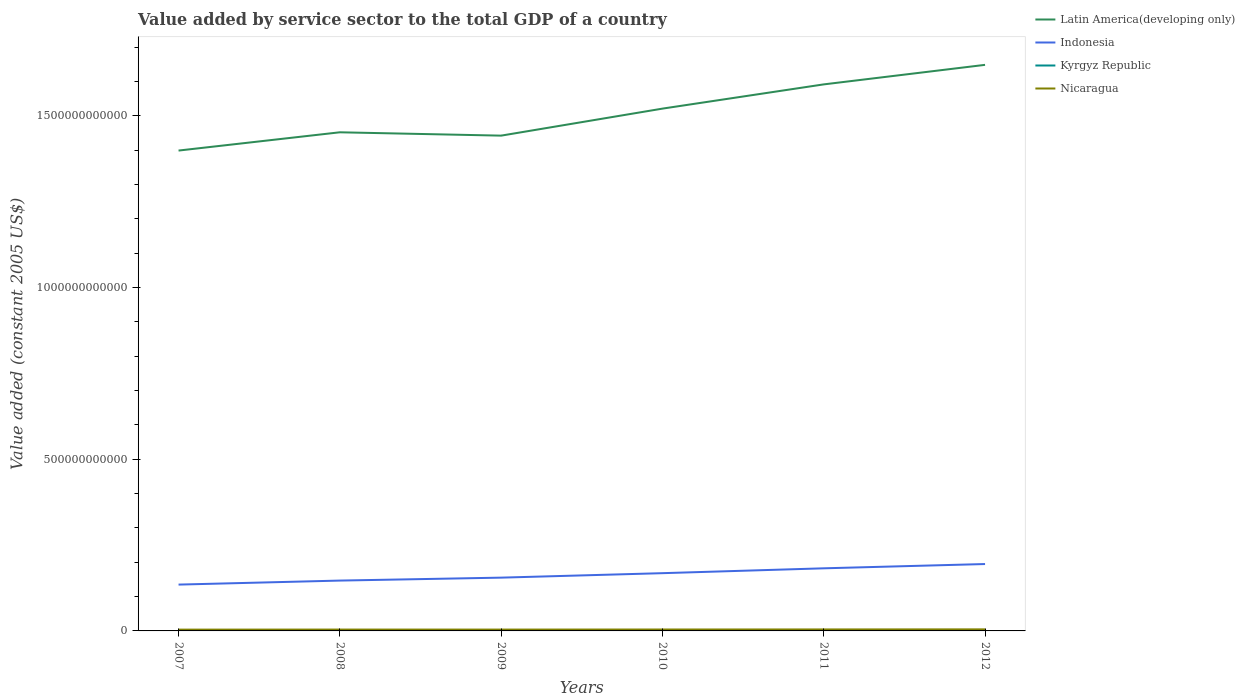How many different coloured lines are there?
Your answer should be very brief. 4. Across all years, what is the maximum value added by service sector in Kyrgyz Republic?
Ensure brevity in your answer.  1.42e+09. In which year was the value added by service sector in Indonesia maximum?
Ensure brevity in your answer.  2007. What is the total value added by service sector in Kyrgyz Republic in the graph?
Your response must be concise. -1.62e+08. What is the difference between the highest and the second highest value added by service sector in Kyrgyz Republic?
Your answer should be very brief. 3.87e+08. Is the value added by service sector in Indonesia strictly greater than the value added by service sector in Latin America(developing only) over the years?
Your answer should be compact. Yes. How many lines are there?
Your response must be concise. 4. How many years are there in the graph?
Provide a short and direct response. 6. What is the difference between two consecutive major ticks on the Y-axis?
Provide a short and direct response. 5.00e+11. Does the graph contain any zero values?
Your answer should be compact. No. How many legend labels are there?
Your response must be concise. 4. How are the legend labels stacked?
Offer a very short reply. Vertical. What is the title of the graph?
Keep it short and to the point. Value added by service sector to the total GDP of a country. Does "Iraq" appear as one of the legend labels in the graph?
Give a very brief answer. No. What is the label or title of the Y-axis?
Keep it short and to the point. Value added (constant 2005 US$). What is the Value added (constant 2005 US$) in Latin America(developing only) in 2007?
Keep it short and to the point. 1.40e+12. What is the Value added (constant 2005 US$) of Indonesia in 2007?
Offer a very short reply. 1.35e+11. What is the Value added (constant 2005 US$) in Kyrgyz Republic in 2007?
Give a very brief answer. 1.42e+09. What is the Value added (constant 2005 US$) in Nicaragua in 2007?
Your response must be concise. 3.76e+09. What is the Value added (constant 2005 US$) in Latin America(developing only) in 2008?
Provide a succinct answer. 1.45e+12. What is the Value added (constant 2005 US$) of Indonesia in 2008?
Your response must be concise. 1.47e+11. What is the Value added (constant 2005 US$) of Kyrgyz Republic in 2008?
Your response must be concise. 1.60e+09. What is the Value added (constant 2005 US$) in Nicaragua in 2008?
Keep it short and to the point. 3.97e+09. What is the Value added (constant 2005 US$) in Latin America(developing only) in 2009?
Offer a terse response. 1.44e+12. What is the Value added (constant 2005 US$) of Indonesia in 2009?
Provide a short and direct response. 1.55e+11. What is the Value added (constant 2005 US$) in Kyrgyz Republic in 2009?
Provide a short and direct response. 1.62e+09. What is the Value added (constant 2005 US$) in Nicaragua in 2009?
Offer a very short reply. 3.93e+09. What is the Value added (constant 2005 US$) of Latin America(developing only) in 2010?
Provide a short and direct response. 1.52e+12. What is the Value added (constant 2005 US$) of Indonesia in 2010?
Offer a terse response. 1.68e+11. What is the Value added (constant 2005 US$) in Kyrgyz Republic in 2010?
Give a very brief answer. 1.62e+09. What is the Value added (constant 2005 US$) of Nicaragua in 2010?
Your answer should be compact. 4.13e+09. What is the Value added (constant 2005 US$) in Latin America(developing only) in 2011?
Your answer should be compact. 1.59e+12. What is the Value added (constant 2005 US$) in Indonesia in 2011?
Keep it short and to the point. 1.82e+11. What is the Value added (constant 2005 US$) of Kyrgyz Republic in 2011?
Give a very brief answer. 1.76e+09. What is the Value added (constant 2005 US$) of Nicaragua in 2011?
Your answer should be very brief. 4.30e+09. What is the Value added (constant 2005 US$) in Latin America(developing only) in 2012?
Provide a succinct answer. 1.65e+12. What is the Value added (constant 2005 US$) of Indonesia in 2012?
Provide a short and direct response. 1.95e+11. What is the Value added (constant 2005 US$) in Kyrgyz Republic in 2012?
Offer a terse response. 1.81e+09. What is the Value added (constant 2005 US$) of Nicaragua in 2012?
Your answer should be very brief. 4.54e+09. Across all years, what is the maximum Value added (constant 2005 US$) in Latin America(developing only)?
Make the answer very short. 1.65e+12. Across all years, what is the maximum Value added (constant 2005 US$) in Indonesia?
Ensure brevity in your answer.  1.95e+11. Across all years, what is the maximum Value added (constant 2005 US$) in Kyrgyz Republic?
Your answer should be very brief. 1.81e+09. Across all years, what is the maximum Value added (constant 2005 US$) in Nicaragua?
Offer a terse response. 4.54e+09. Across all years, what is the minimum Value added (constant 2005 US$) of Latin America(developing only)?
Offer a very short reply. 1.40e+12. Across all years, what is the minimum Value added (constant 2005 US$) in Indonesia?
Ensure brevity in your answer.  1.35e+11. Across all years, what is the minimum Value added (constant 2005 US$) in Kyrgyz Republic?
Offer a very short reply. 1.42e+09. Across all years, what is the minimum Value added (constant 2005 US$) in Nicaragua?
Keep it short and to the point. 3.76e+09. What is the total Value added (constant 2005 US$) in Latin America(developing only) in the graph?
Your answer should be very brief. 9.05e+12. What is the total Value added (constant 2005 US$) in Indonesia in the graph?
Provide a succinct answer. 9.82e+11. What is the total Value added (constant 2005 US$) in Kyrgyz Republic in the graph?
Ensure brevity in your answer.  9.84e+09. What is the total Value added (constant 2005 US$) of Nicaragua in the graph?
Provide a succinct answer. 2.46e+1. What is the difference between the Value added (constant 2005 US$) in Latin America(developing only) in 2007 and that in 2008?
Provide a short and direct response. -5.32e+1. What is the difference between the Value added (constant 2005 US$) in Indonesia in 2007 and that in 2008?
Your answer should be compact. -1.17e+1. What is the difference between the Value added (constant 2005 US$) in Kyrgyz Republic in 2007 and that in 2008?
Your answer should be very brief. -1.81e+08. What is the difference between the Value added (constant 2005 US$) of Nicaragua in 2007 and that in 2008?
Offer a terse response. -2.14e+08. What is the difference between the Value added (constant 2005 US$) of Latin America(developing only) in 2007 and that in 2009?
Your answer should be very brief. -4.35e+1. What is the difference between the Value added (constant 2005 US$) of Indonesia in 2007 and that in 2009?
Provide a short and direct response. -2.02e+1. What is the difference between the Value added (constant 2005 US$) in Kyrgyz Republic in 2007 and that in 2009?
Your answer should be very brief. -1.99e+08. What is the difference between the Value added (constant 2005 US$) of Nicaragua in 2007 and that in 2009?
Ensure brevity in your answer.  -1.70e+08. What is the difference between the Value added (constant 2005 US$) of Latin America(developing only) in 2007 and that in 2010?
Your answer should be compact. -1.22e+11. What is the difference between the Value added (constant 2005 US$) in Indonesia in 2007 and that in 2010?
Your answer should be compact. -3.33e+1. What is the difference between the Value added (constant 2005 US$) in Kyrgyz Republic in 2007 and that in 2010?
Give a very brief answer. -2.02e+08. What is the difference between the Value added (constant 2005 US$) of Nicaragua in 2007 and that in 2010?
Offer a very short reply. -3.67e+08. What is the difference between the Value added (constant 2005 US$) in Latin America(developing only) in 2007 and that in 2011?
Make the answer very short. -1.93e+11. What is the difference between the Value added (constant 2005 US$) of Indonesia in 2007 and that in 2011?
Your answer should be compact. -4.74e+1. What is the difference between the Value added (constant 2005 US$) in Kyrgyz Republic in 2007 and that in 2011?
Offer a very short reply. -3.42e+08. What is the difference between the Value added (constant 2005 US$) of Nicaragua in 2007 and that in 2011?
Offer a terse response. -5.40e+08. What is the difference between the Value added (constant 2005 US$) in Latin America(developing only) in 2007 and that in 2012?
Keep it short and to the point. -2.50e+11. What is the difference between the Value added (constant 2005 US$) of Indonesia in 2007 and that in 2012?
Offer a very short reply. -5.98e+1. What is the difference between the Value added (constant 2005 US$) of Kyrgyz Republic in 2007 and that in 2012?
Give a very brief answer. -3.87e+08. What is the difference between the Value added (constant 2005 US$) of Nicaragua in 2007 and that in 2012?
Offer a very short reply. -7.78e+08. What is the difference between the Value added (constant 2005 US$) of Latin America(developing only) in 2008 and that in 2009?
Your answer should be compact. 9.73e+09. What is the difference between the Value added (constant 2005 US$) of Indonesia in 2008 and that in 2009?
Provide a succinct answer. -8.54e+09. What is the difference between the Value added (constant 2005 US$) in Kyrgyz Republic in 2008 and that in 2009?
Your answer should be compact. -1.82e+07. What is the difference between the Value added (constant 2005 US$) of Nicaragua in 2008 and that in 2009?
Provide a short and direct response. 4.43e+07. What is the difference between the Value added (constant 2005 US$) in Latin America(developing only) in 2008 and that in 2010?
Your response must be concise. -6.89e+1. What is the difference between the Value added (constant 2005 US$) in Indonesia in 2008 and that in 2010?
Offer a terse response. -2.16e+1. What is the difference between the Value added (constant 2005 US$) of Kyrgyz Republic in 2008 and that in 2010?
Ensure brevity in your answer.  -2.15e+07. What is the difference between the Value added (constant 2005 US$) in Nicaragua in 2008 and that in 2010?
Make the answer very short. -1.53e+08. What is the difference between the Value added (constant 2005 US$) of Latin America(developing only) in 2008 and that in 2011?
Keep it short and to the point. -1.39e+11. What is the difference between the Value added (constant 2005 US$) of Indonesia in 2008 and that in 2011?
Make the answer very short. -3.57e+1. What is the difference between the Value added (constant 2005 US$) in Kyrgyz Republic in 2008 and that in 2011?
Your answer should be compact. -1.62e+08. What is the difference between the Value added (constant 2005 US$) of Nicaragua in 2008 and that in 2011?
Your response must be concise. -3.26e+08. What is the difference between the Value added (constant 2005 US$) of Latin America(developing only) in 2008 and that in 2012?
Offer a very short reply. -1.96e+11. What is the difference between the Value added (constant 2005 US$) in Indonesia in 2008 and that in 2012?
Make the answer very short. -4.82e+1. What is the difference between the Value added (constant 2005 US$) in Kyrgyz Republic in 2008 and that in 2012?
Your answer should be very brief. -2.06e+08. What is the difference between the Value added (constant 2005 US$) in Nicaragua in 2008 and that in 2012?
Make the answer very short. -5.63e+08. What is the difference between the Value added (constant 2005 US$) in Latin America(developing only) in 2009 and that in 2010?
Offer a terse response. -7.86e+1. What is the difference between the Value added (constant 2005 US$) of Indonesia in 2009 and that in 2010?
Your response must be concise. -1.31e+1. What is the difference between the Value added (constant 2005 US$) in Kyrgyz Republic in 2009 and that in 2010?
Provide a short and direct response. -3.38e+06. What is the difference between the Value added (constant 2005 US$) of Nicaragua in 2009 and that in 2010?
Your response must be concise. -1.97e+08. What is the difference between the Value added (constant 2005 US$) of Latin America(developing only) in 2009 and that in 2011?
Your response must be concise. -1.49e+11. What is the difference between the Value added (constant 2005 US$) in Indonesia in 2009 and that in 2011?
Offer a very short reply. -2.72e+1. What is the difference between the Value added (constant 2005 US$) in Kyrgyz Republic in 2009 and that in 2011?
Provide a succinct answer. -1.43e+08. What is the difference between the Value added (constant 2005 US$) in Nicaragua in 2009 and that in 2011?
Your answer should be very brief. -3.70e+08. What is the difference between the Value added (constant 2005 US$) in Latin America(developing only) in 2009 and that in 2012?
Keep it short and to the point. -2.06e+11. What is the difference between the Value added (constant 2005 US$) of Indonesia in 2009 and that in 2012?
Give a very brief answer. -3.96e+1. What is the difference between the Value added (constant 2005 US$) of Kyrgyz Republic in 2009 and that in 2012?
Your answer should be compact. -1.88e+08. What is the difference between the Value added (constant 2005 US$) in Nicaragua in 2009 and that in 2012?
Provide a short and direct response. -6.08e+08. What is the difference between the Value added (constant 2005 US$) in Latin America(developing only) in 2010 and that in 2011?
Offer a terse response. -7.06e+1. What is the difference between the Value added (constant 2005 US$) of Indonesia in 2010 and that in 2011?
Give a very brief answer. -1.41e+1. What is the difference between the Value added (constant 2005 US$) in Kyrgyz Republic in 2010 and that in 2011?
Keep it short and to the point. -1.40e+08. What is the difference between the Value added (constant 2005 US$) of Nicaragua in 2010 and that in 2011?
Your answer should be compact. -1.73e+08. What is the difference between the Value added (constant 2005 US$) of Latin America(developing only) in 2010 and that in 2012?
Your answer should be compact. -1.27e+11. What is the difference between the Value added (constant 2005 US$) in Indonesia in 2010 and that in 2012?
Ensure brevity in your answer.  -2.66e+1. What is the difference between the Value added (constant 2005 US$) in Kyrgyz Republic in 2010 and that in 2012?
Keep it short and to the point. -1.84e+08. What is the difference between the Value added (constant 2005 US$) of Nicaragua in 2010 and that in 2012?
Provide a short and direct response. -4.10e+08. What is the difference between the Value added (constant 2005 US$) of Latin America(developing only) in 2011 and that in 2012?
Provide a short and direct response. -5.69e+1. What is the difference between the Value added (constant 2005 US$) of Indonesia in 2011 and that in 2012?
Offer a very short reply. -1.24e+1. What is the difference between the Value added (constant 2005 US$) of Kyrgyz Republic in 2011 and that in 2012?
Provide a succinct answer. -4.44e+07. What is the difference between the Value added (constant 2005 US$) of Nicaragua in 2011 and that in 2012?
Your response must be concise. -2.38e+08. What is the difference between the Value added (constant 2005 US$) of Latin America(developing only) in 2007 and the Value added (constant 2005 US$) of Indonesia in 2008?
Your answer should be very brief. 1.25e+12. What is the difference between the Value added (constant 2005 US$) of Latin America(developing only) in 2007 and the Value added (constant 2005 US$) of Kyrgyz Republic in 2008?
Your answer should be compact. 1.40e+12. What is the difference between the Value added (constant 2005 US$) in Latin America(developing only) in 2007 and the Value added (constant 2005 US$) in Nicaragua in 2008?
Ensure brevity in your answer.  1.39e+12. What is the difference between the Value added (constant 2005 US$) of Indonesia in 2007 and the Value added (constant 2005 US$) of Kyrgyz Republic in 2008?
Offer a very short reply. 1.33e+11. What is the difference between the Value added (constant 2005 US$) of Indonesia in 2007 and the Value added (constant 2005 US$) of Nicaragua in 2008?
Offer a very short reply. 1.31e+11. What is the difference between the Value added (constant 2005 US$) in Kyrgyz Republic in 2007 and the Value added (constant 2005 US$) in Nicaragua in 2008?
Your answer should be compact. -2.55e+09. What is the difference between the Value added (constant 2005 US$) of Latin America(developing only) in 2007 and the Value added (constant 2005 US$) of Indonesia in 2009?
Give a very brief answer. 1.24e+12. What is the difference between the Value added (constant 2005 US$) in Latin America(developing only) in 2007 and the Value added (constant 2005 US$) in Kyrgyz Republic in 2009?
Keep it short and to the point. 1.40e+12. What is the difference between the Value added (constant 2005 US$) of Latin America(developing only) in 2007 and the Value added (constant 2005 US$) of Nicaragua in 2009?
Provide a short and direct response. 1.39e+12. What is the difference between the Value added (constant 2005 US$) in Indonesia in 2007 and the Value added (constant 2005 US$) in Kyrgyz Republic in 2009?
Make the answer very short. 1.33e+11. What is the difference between the Value added (constant 2005 US$) in Indonesia in 2007 and the Value added (constant 2005 US$) in Nicaragua in 2009?
Your answer should be very brief. 1.31e+11. What is the difference between the Value added (constant 2005 US$) in Kyrgyz Republic in 2007 and the Value added (constant 2005 US$) in Nicaragua in 2009?
Make the answer very short. -2.51e+09. What is the difference between the Value added (constant 2005 US$) in Latin America(developing only) in 2007 and the Value added (constant 2005 US$) in Indonesia in 2010?
Make the answer very short. 1.23e+12. What is the difference between the Value added (constant 2005 US$) in Latin America(developing only) in 2007 and the Value added (constant 2005 US$) in Kyrgyz Republic in 2010?
Provide a succinct answer. 1.40e+12. What is the difference between the Value added (constant 2005 US$) in Latin America(developing only) in 2007 and the Value added (constant 2005 US$) in Nicaragua in 2010?
Provide a short and direct response. 1.39e+12. What is the difference between the Value added (constant 2005 US$) of Indonesia in 2007 and the Value added (constant 2005 US$) of Kyrgyz Republic in 2010?
Ensure brevity in your answer.  1.33e+11. What is the difference between the Value added (constant 2005 US$) of Indonesia in 2007 and the Value added (constant 2005 US$) of Nicaragua in 2010?
Offer a very short reply. 1.31e+11. What is the difference between the Value added (constant 2005 US$) in Kyrgyz Republic in 2007 and the Value added (constant 2005 US$) in Nicaragua in 2010?
Your answer should be very brief. -2.71e+09. What is the difference between the Value added (constant 2005 US$) in Latin America(developing only) in 2007 and the Value added (constant 2005 US$) in Indonesia in 2011?
Your answer should be very brief. 1.22e+12. What is the difference between the Value added (constant 2005 US$) of Latin America(developing only) in 2007 and the Value added (constant 2005 US$) of Kyrgyz Republic in 2011?
Your response must be concise. 1.40e+12. What is the difference between the Value added (constant 2005 US$) of Latin America(developing only) in 2007 and the Value added (constant 2005 US$) of Nicaragua in 2011?
Provide a succinct answer. 1.39e+12. What is the difference between the Value added (constant 2005 US$) of Indonesia in 2007 and the Value added (constant 2005 US$) of Kyrgyz Republic in 2011?
Your answer should be very brief. 1.33e+11. What is the difference between the Value added (constant 2005 US$) of Indonesia in 2007 and the Value added (constant 2005 US$) of Nicaragua in 2011?
Give a very brief answer. 1.31e+11. What is the difference between the Value added (constant 2005 US$) of Kyrgyz Republic in 2007 and the Value added (constant 2005 US$) of Nicaragua in 2011?
Keep it short and to the point. -2.88e+09. What is the difference between the Value added (constant 2005 US$) of Latin America(developing only) in 2007 and the Value added (constant 2005 US$) of Indonesia in 2012?
Keep it short and to the point. 1.20e+12. What is the difference between the Value added (constant 2005 US$) in Latin America(developing only) in 2007 and the Value added (constant 2005 US$) in Kyrgyz Republic in 2012?
Offer a terse response. 1.40e+12. What is the difference between the Value added (constant 2005 US$) of Latin America(developing only) in 2007 and the Value added (constant 2005 US$) of Nicaragua in 2012?
Offer a very short reply. 1.39e+12. What is the difference between the Value added (constant 2005 US$) in Indonesia in 2007 and the Value added (constant 2005 US$) in Kyrgyz Republic in 2012?
Keep it short and to the point. 1.33e+11. What is the difference between the Value added (constant 2005 US$) in Indonesia in 2007 and the Value added (constant 2005 US$) in Nicaragua in 2012?
Make the answer very short. 1.30e+11. What is the difference between the Value added (constant 2005 US$) in Kyrgyz Republic in 2007 and the Value added (constant 2005 US$) in Nicaragua in 2012?
Make the answer very short. -3.12e+09. What is the difference between the Value added (constant 2005 US$) in Latin America(developing only) in 2008 and the Value added (constant 2005 US$) in Indonesia in 2009?
Offer a terse response. 1.30e+12. What is the difference between the Value added (constant 2005 US$) in Latin America(developing only) in 2008 and the Value added (constant 2005 US$) in Kyrgyz Republic in 2009?
Ensure brevity in your answer.  1.45e+12. What is the difference between the Value added (constant 2005 US$) in Latin America(developing only) in 2008 and the Value added (constant 2005 US$) in Nicaragua in 2009?
Your answer should be compact. 1.45e+12. What is the difference between the Value added (constant 2005 US$) in Indonesia in 2008 and the Value added (constant 2005 US$) in Kyrgyz Republic in 2009?
Your answer should be compact. 1.45e+11. What is the difference between the Value added (constant 2005 US$) in Indonesia in 2008 and the Value added (constant 2005 US$) in Nicaragua in 2009?
Keep it short and to the point. 1.43e+11. What is the difference between the Value added (constant 2005 US$) in Kyrgyz Republic in 2008 and the Value added (constant 2005 US$) in Nicaragua in 2009?
Offer a terse response. -2.33e+09. What is the difference between the Value added (constant 2005 US$) in Latin America(developing only) in 2008 and the Value added (constant 2005 US$) in Indonesia in 2010?
Provide a short and direct response. 1.28e+12. What is the difference between the Value added (constant 2005 US$) in Latin America(developing only) in 2008 and the Value added (constant 2005 US$) in Kyrgyz Republic in 2010?
Offer a very short reply. 1.45e+12. What is the difference between the Value added (constant 2005 US$) in Latin America(developing only) in 2008 and the Value added (constant 2005 US$) in Nicaragua in 2010?
Offer a terse response. 1.45e+12. What is the difference between the Value added (constant 2005 US$) in Indonesia in 2008 and the Value added (constant 2005 US$) in Kyrgyz Republic in 2010?
Your answer should be very brief. 1.45e+11. What is the difference between the Value added (constant 2005 US$) in Indonesia in 2008 and the Value added (constant 2005 US$) in Nicaragua in 2010?
Make the answer very short. 1.42e+11. What is the difference between the Value added (constant 2005 US$) of Kyrgyz Republic in 2008 and the Value added (constant 2005 US$) of Nicaragua in 2010?
Make the answer very short. -2.53e+09. What is the difference between the Value added (constant 2005 US$) in Latin America(developing only) in 2008 and the Value added (constant 2005 US$) in Indonesia in 2011?
Ensure brevity in your answer.  1.27e+12. What is the difference between the Value added (constant 2005 US$) in Latin America(developing only) in 2008 and the Value added (constant 2005 US$) in Kyrgyz Republic in 2011?
Make the answer very short. 1.45e+12. What is the difference between the Value added (constant 2005 US$) of Latin America(developing only) in 2008 and the Value added (constant 2005 US$) of Nicaragua in 2011?
Your answer should be compact. 1.45e+12. What is the difference between the Value added (constant 2005 US$) of Indonesia in 2008 and the Value added (constant 2005 US$) of Kyrgyz Republic in 2011?
Provide a short and direct response. 1.45e+11. What is the difference between the Value added (constant 2005 US$) in Indonesia in 2008 and the Value added (constant 2005 US$) in Nicaragua in 2011?
Provide a succinct answer. 1.42e+11. What is the difference between the Value added (constant 2005 US$) of Kyrgyz Republic in 2008 and the Value added (constant 2005 US$) of Nicaragua in 2011?
Provide a succinct answer. -2.70e+09. What is the difference between the Value added (constant 2005 US$) in Latin America(developing only) in 2008 and the Value added (constant 2005 US$) in Indonesia in 2012?
Your answer should be compact. 1.26e+12. What is the difference between the Value added (constant 2005 US$) in Latin America(developing only) in 2008 and the Value added (constant 2005 US$) in Kyrgyz Republic in 2012?
Provide a short and direct response. 1.45e+12. What is the difference between the Value added (constant 2005 US$) in Latin America(developing only) in 2008 and the Value added (constant 2005 US$) in Nicaragua in 2012?
Make the answer very short. 1.45e+12. What is the difference between the Value added (constant 2005 US$) of Indonesia in 2008 and the Value added (constant 2005 US$) of Kyrgyz Republic in 2012?
Make the answer very short. 1.45e+11. What is the difference between the Value added (constant 2005 US$) in Indonesia in 2008 and the Value added (constant 2005 US$) in Nicaragua in 2012?
Ensure brevity in your answer.  1.42e+11. What is the difference between the Value added (constant 2005 US$) in Kyrgyz Republic in 2008 and the Value added (constant 2005 US$) in Nicaragua in 2012?
Provide a succinct answer. -2.94e+09. What is the difference between the Value added (constant 2005 US$) in Latin America(developing only) in 2009 and the Value added (constant 2005 US$) in Indonesia in 2010?
Offer a very short reply. 1.27e+12. What is the difference between the Value added (constant 2005 US$) in Latin America(developing only) in 2009 and the Value added (constant 2005 US$) in Kyrgyz Republic in 2010?
Your answer should be compact. 1.44e+12. What is the difference between the Value added (constant 2005 US$) in Latin America(developing only) in 2009 and the Value added (constant 2005 US$) in Nicaragua in 2010?
Ensure brevity in your answer.  1.44e+12. What is the difference between the Value added (constant 2005 US$) of Indonesia in 2009 and the Value added (constant 2005 US$) of Kyrgyz Republic in 2010?
Make the answer very short. 1.53e+11. What is the difference between the Value added (constant 2005 US$) in Indonesia in 2009 and the Value added (constant 2005 US$) in Nicaragua in 2010?
Provide a short and direct response. 1.51e+11. What is the difference between the Value added (constant 2005 US$) of Kyrgyz Republic in 2009 and the Value added (constant 2005 US$) of Nicaragua in 2010?
Your answer should be compact. -2.51e+09. What is the difference between the Value added (constant 2005 US$) in Latin America(developing only) in 2009 and the Value added (constant 2005 US$) in Indonesia in 2011?
Provide a short and direct response. 1.26e+12. What is the difference between the Value added (constant 2005 US$) of Latin America(developing only) in 2009 and the Value added (constant 2005 US$) of Kyrgyz Republic in 2011?
Provide a short and direct response. 1.44e+12. What is the difference between the Value added (constant 2005 US$) in Latin America(developing only) in 2009 and the Value added (constant 2005 US$) in Nicaragua in 2011?
Your response must be concise. 1.44e+12. What is the difference between the Value added (constant 2005 US$) of Indonesia in 2009 and the Value added (constant 2005 US$) of Kyrgyz Republic in 2011?
Your answer should be compact. 1.53e+11. What is the difference between the Value added (constant 2005 US$) in Indonesia in 2009 and the Value added (constant 2005 US$) in Nicaragua in 2011?
Offer a very short reply. 1.51e+11. What is the difference between the Value added (constant 2005 US$) in Kyrgyz Republic in 2009 and the Value added (constant 2005 US$) in Nicaragua in 2011?
Keep it short and to the point. -2.68e+09. What is the difference between the Value added (constant 2005 US$) of Latin America(developing only) in 2009 and the Value added (constant 2005 US$) of Indonesia in 2012?
Your answer should be compact. 1.25e+12. What is the difference between the Value added (constant 2005 US$) of Latin America(developing only) in 2009 and the Value added (constant 2005 US$) of Kyrgyz Republic in 2012?
Ensure brevity in your answer.  1.44e+12. What is the difference between the Value added (constant 2005 US$) of Latin America(developing only) in 2009 and the Value added (constant 2005 US$) of Nicaragua in 2012?
Ensure brevity in your answer.  1.44e+12. What is the difference between the Value added (constant 2005 US$) of Indonesia in 2009 and the Value added (constant 2005 US$) of Kyrgyz Republic in 2012?
Make the answer very short. 1.53e+11. What is the difference between the Value added (constant 2005 US$) of Indonesia in 2009 and the Value added (constant 2005 US$) of Nicaragua in 2012?
Make the answer very short. 1.51e+11. What is the difference between the Value added (constant 2005 US$) in Kyrgyz Republic in 2009 and the Value added (constant 2005 US$) in Nicaragua in 2012?
Your response must be concise. -2.92e+09. What is the difference between the Value added (constant 2005 US$) of Latin America(developing only) in 2010 and the Value added (constant 2005 US$) of Indonesia in 2011?
Ensure brevity in your answer.  1.34e+12. What is the difference between the Value added (constant 2005 US$) in Latin America(developing only) in 2010 and the Value added (constant 2005 US$) in Kyrgyz Republic in 2011?
Provide a succinct answer. 1.52e+12. What is the difference between the Value added (constant 2005 US$) of Latin America(developing only) in 2010 and the Value added (constant 2005 US$) of Nicaragua in 2011?
Ensure brevity in your answer.  1.52e+12. What is the difference between the Value added (constant 2005 US$) of Indonesia in 2010 and the Value added (constant 2005 US$) of Kyrgyz Republic in 2011?
Provide a short and direct response. 1.66e+11. What is the difference between the Value added (constant 2005 US$) in Indonesia in 2010 and the Value added (constant 2005 US$) in Nicaragua in 2011?
Keep it short and to the point. 1.64e+11. What is the difference between the Value added (constant 2005 US$) of Kyrgyz Republic in 2010 and the Value added (constant 2005 US$) of Nicaragua in 2011?
Your response must be concise. -2.68e+09. What is the difference between the Value added (constant 2005 US$) of Latin America(developing only) in 2010 and the Value added (constant 2005 US$) of Indonesia in 2012?
Ensure brevity in your answer.  1.33e+12. What is the difference between the Value added (constant 2005 US$) in Latin America(developing only) in 2010 and the Value added (constant 2005 US$) in Kyrgyz Republic in 2012?
Provide a succinct answer. 1.52e+12. What is the difference between the Value added (constant 2005 US$) in Latin America(developing only) in 2010 and the Value added (constant 2005 US$) in Nicaragua in 2012?
Ensure brevity in your answer.  1.52e+12. What is the difference between the Value added (constant 2005 US$) of Indonesia in 2010 and the Value added (constant 2005 US$) of Kyrgyz Republic in 2012?
Ensure brevity in your answer.  1.66e+11. What is the difference between the Value added (constant 2005 US$) of Indonesia in 2010 and the Value added (constant 2005 US$) of Nicaragua in 2012?
Offer a very short reply. 1.64e+11. What is the difference between the Value added (constant 2005 US$) in Kyrgyz Republic in 2010 and the Value added (constant 2005 US$) in Nicaragua in 2012?
Your answer should be very brief. -2.91e+09. What is the difference between the Value added (constant 2005 US$) in Latin America(developing only) in 2011 and the Value added (constant 2005 US$) in Indonesia in 2012?
Provide a short and direct response. 1.40e+12. What is the difference between the Value added (constant 2005 US$) of Latin America(developing only) in 2011 and the Value added (constant 2005 US$) of Kyrgyz Republic in 2012?
Provide a short and direct response. 1.59e+12. What is the difference between the Value added (constant 2005 US$) of Latin America(developing only) in 2011 and the Value added (constant 2005 US$) of Nicaragua in 2012?
Give a very brief answer. 1.59e+12. What is the difference between the Value added (constant 2005 US$) in Indonesia in 2011 and the Value added (constant 2005 US$) in Kyrgyz Republic in 2012?
Offer a terse response. 1.80e+11. What is the difference between the Value added (constant 2005 US$) of Indonesia in 2011 and the Value added (constant 2005 US$) of Nicaragua in 2012?
Provide a succinct answer. 1.78e+11. What is the difference between the Value added (constant 2005 US$) of Kyrgyz Republic in 2011 and the Value added (constant 2005 US$) of Nicaragua in 2012?
Your answer should be very brief. -2.77e+09. What is the average Value added (constant 2005 US$) in Latin America(developing only) per year?
Offer a very short reply. 1.51e+12. What is the average Value added (constant 2005 US$) of Indonesia per year?
Offer a very short reply. 1.64e+11. What is the average Value added (constant 2005 US$) of Kyrgyz Republic per year?
Ensure brevity in your answer.  1.64e+09. What is the average Value added (constant 2005 US$) of Nicaragua per year?
Your response must be concise. 4.11e+09. In the year 2007, what is the difference between the Value added (constant 2005 US$) in Latin America(developing only) and Value added (constant 2005 US$) in Indonesia?
Offer a terse response. 1.26e+12. In the year 2007, what is the difference between the Value added (constant 2005 US$) in Latin America(developing only) and Value added (constant 2005 US$) in Kyrgyz Republic?
Your response must be concise. 1.40e+12. In the year 2007, what is the difference between the Value added (constant 2005 US$) of Latin America(developing only) and Value added (constant 2005 US$) of Nicaragua?
Your response must be concise. 1.39e+12. In the year 2007, what is the difference between the Value added (constant 2005 US$) in Indonesia and Value added (constant 2005 US$) in Kyrgyz Republic?
Your response must be concise. 1.33e+11. In the year 2007, what is the difference between the Value added (constant 2005 US$) in Indonesia and Value added (constant 2005 US$) in Nicaragua?
Offer a very short reply. 1.31e+11. In the year 2007, what is the difference between the Value added (constant 2005 US$) of Kyrgyz Republic and Value added (constant 2005 US$) of Nicaragua?
Your answer should be very brief. -2.34e+09. In the year 2008, what is the difference between the Value added (constant 2005 US$) in Latin America(developing only) and Value added (constant 2005 US$) in Indonesia?
Offer a very short reply. 1.31e+12. In the year 2008, what is the difference between the Value added (constant 2005 US$) in Latin America(developing only) and Value added (constant 2005 US$) in Kyrgyz Republic?
Offer a terse response. 1.45e+12. In the year 2008, what is the difference between the Value added (constant 2005 US$) of Latin America(developing only) and Value added (constant 2005 US$) of Nicaragua?
Ensure brevity in your answer.  1.45e+12. In the year 2008, what is the difference between the Value added (constant 2005 US$) in Indonesia and Value added (constant 2005 US$) in Kyrgyz Republic?
Offer a terse response. 1.45e+11. In the year 2008, what is the difference between the Value added (constant 2005 US$) in Indonesia and Value added (constant 2005 US$) in Nicaragua?
Offer a terse response. 1.43e+11. In the year 2008, what is the difference between the Value added (constant 2005 US$) in Kyrgyz Republic and Value added (constant 2005 US$) in Nicaragua?
Provide a short and direct response. -2.37e+09. In the year 2009, what is the difference between the Value added (constant 2005 US$) of Latin America(developing only) and Value added (constant 2005 US$) of Indonesia?
Ensure brevity in your answer.  1.29e+12. In the year 2009, what is the difference between the Value added (constant 2005 US$) in Latin America(developing only) and Value added (constant 2005 US$) in Kyrgyz Republic?
Your answer should be compact. 1.44e+12. In the year 2009, what is the difference between the Value added (constant 2005 US$) of Latin America(developing only) and Value added (constant 2005 US$) of Nicaragua?
Offer a terse response. 1.44e+12. In the year 2009, what is the difference between the Value added (constant 2005 US$) in Indonesia and Value added (constant 2005 US$) in Kyrgyz Republic?
Provide a succinct answer. 1.53e+11. In the year 2009, what is the difference between the Value added (constant 2005 US$) in Indonesia and Value added (constant 2005 US$) in Nicaragua?
Your answer should be very brief. 1.51e+11. In the year 2009, what is the difference between the Value added (constant 2005 US$) of Kyrgyz Republic and Value added (constant 2005 US$) of Nicaragua?
Offer a very short reply. -2.31e+09. In the year 2010, what is the difference between the Value added (constant 2005 US$) in Latin America(developing only) and Value added (constant 2005 US$) in Indonesia?
Your response must be concise. 1.35e+12. In the year 2010, what is the difference between the Value added (constant 2005 US$) of Latin America(developing only) and Value added (constant 2005 US$) of Kyrgyz Republic?
Your answer should be compact. 1.52e+12. In the year 2010, what is the difference between the Value added (constant 2005 US$) in Latin America(developing only) and Value added (constant 2005 US$) in Nicaragua?
Make the answer very short. 1.52e+12. In the year 2010, what is the difference between the Value added (constant 2005 US$) of Indonesia and Value added (constant 2005 US$) of Kyrgyz Republic?
Give a very brief answer. 1.67e+11. In the year 2010, what is the difference between the Value added (constant 2005 US$) of Indonesia and Value added (constant 2005 US$) of Nicaragua?
Give a very brief answer. 1.64e+11. In the year 2010, what is the difference between the Value added (constant 2005 US$) of Kyrgyz Republic and Value added (constant 2005 US$) of Nicaragua?
Offer a very short reply. -2.50e+09. In the year 2011, what is the difference between the Value added (constant 2005 US$) of Latin America(developing only) and Value added (constant 2005 US$) of Indonesia?
Make the answer very short. 1.41e+12. In the year 2011, what is the difference between the Value added (constant 2005 US$) in Latin America(developing only) and Value added (constant 2005 US$) in Kyrgyz Republic?
Ensure brevity in your answer.  1.59e+12. In the year 2011, what is the difference between the Value added (constant 2005 US$) in Latin America(developing only) and Value added (constant 2005 US$) in Nicaragua?
Your response must be concise. 1.59e+12. In the year 2011, what is the difference between the Value added (constant 2005 US$) in Indonesia and Value added (constant 2005 US$) in Kyrgyz Republic?
Provide a short and direct response. 1.81e+11. In the year 2011, what is the difference between the Value added (constant 2005 US$) in Indonesia and Value added (constant 2005 US$) in Nicaragua?
Provide a short and direct response. 1.78e+11. In the year 2011, what is the difference between the Value added (constant 2005 US$) in Kyrgyz Republic and Value added (constant 2005 US$) in Nicaragua?
Your response must be concise. -2.54e+09. In the year 2012, what is the difference between the Value added (constant 2005 US$) of Latin America(developing only) and Value added (constant 2005 US$) of Indonesia?
Offer a very short reply. 1.45e+12. In the year 2012, what is the difference between the Value added (constant 2005 US$) in Latin America(developing only) and Value added (constant 2005 US$) in Kyrgyz Republic?
Ensure brevity in your answer.  1.65e+12. In the year 2012, what is the difference between the Value added (constant 2005 US$) in Latin America(developing only) and Value added (constant 2005 US$) in Nicaragua?
Provide a short and direct response. 1.64e+12. In the year 2012, what is the difference between the Value added (constant 2005 US$) in Indonesia and Value added (constant 2005 US$) in Kyrgyz Republic?
Offer a terse response. 1.93e+11. In the year 2012, what is the difference between the Value added (constant 2005 US$) of Indonesia and Value added (constant 2005 US$) of Nicaragua?
Offer a very short reply. 1.90e+11. In the year 2012, what is the difference between the Value added (constant 2005 US$) of Kyrgyz Republic and Value added (constant 2005 US$) of Nicaragua?
Your answer should be compact. -2.73e+09. What is the ratio of the Value added (constant 2005 US$) of Latin America(developing only) in 2007 to that in 2008?
Provide a succinct answer. 0.96. What is the ratio of the Value added (constant 2005 US$) of Indonesia in 2007 to that in 2008?
Provide a short and direct response. 0.92. What is the ratio of the Value added (constant 2005 US$) in Kyrgyz Republic in 2007 to that in 2008?
Ensure brevity in your answer.  0.89. What is the ratio of the Value added (constant 2005 US$) of Nicaragua in 2007 to that in 2008?
Provide a short and direct response. 0.95. What is the ratio of the Value added (constant 2005 US$) of Latin America(developing only) in 2007 to that in 2009?
Your answer should be very brief. 0.97. What is the ratio of the Value added (constant 2005 US$) in Indonesia in 2007 to that in 2009?
Make the answer very short. 0.87. What is the ratio of the Value added (constant 2005 US$) in Kyrgyz Republic in 2007 to that in 2009?
Keep it short and to the point. 0.88. What is the ratio of the Value added (constant 2005 US$) in Nicaragua in 2007 to that in 2009?
Ensure brevity in your answer.  0.96. What is the ratio of the Value added (constant 2005 US$) of Latin America(developing only) in 2007 to that in 2010?
Keep it short and to the point. 0.92. What is the ratio of the Value added (constant 2005 US$) of Indonesia in 2007 to that in 2010?
Your response must be concise. 0.8. What is the ratio of the Value added (constant 2005 US$) in Kyrgyz Republic in 2007 to that in 2010?
Offer a terse response. 0.88. What is the ratio of the Value added (constant 2005 US$) in Nicaragua in 2007 to that in 2010?
Offer a very short reply. 0.91. What is the ratio of the Value added (constant 2005 US$) in Latin America(developing only) in 2007 to that in 2011?
Your response must be concise. 0.88. What is the ratio of the Value added (constant 2005 US$) of Indonesia in 2007 to that in 2011?
Your response must be concise. 0.74. What is the ratio of the Value added (constant 2005 US$) in Kyrgyz Republic in 2007 to that in 2011?
Provide a succinct answer. 0.81. What is the ratio of the Value added (constant 2005 US$) of Nicaragua in 2007 to that in 2011?
Provide a succinct answer. 0.87. What is the ratio of the Value added (constant 2005 US$) of Latin America(developing only) in 2007 to that in 2012?
Your response must be concise. 0.85. What is the ratio of the Value added (constant 2005 US$) of Indonesia in 2007 to that in 2012?
Offer a terse response. 0.69. What is the ratio of the Value added (constant 2005 US$) in Kyrgyz Republic in 2007 to that in 2012?
Provide a short and direct response. 0.79. What is the ratio of the Value added (constant 2005 US$) of Nicaragua in 2007 to that in 2012?
Keep it short and to the point. 0.83. What is the ratio of the Value added (constant 2005 US$) of Indonesia in 2008 to that in 2009?
Offer a terse response. 0.94. What is the ratio of the Value added (constant 2005 US$) of Nicaragua in 2008 to that in 2009?
Offer a very short reply. 1.01. What is the ratio of the Value added (constant 2005 US$) in Latin America(developing only) in 2008 to that in 2010?
Your response must be concise. 0.95. What is the ratio of the Value added (constant 2005 US$) of Indonesia in 2008 to that in 2010?
Your answer should be compact. 0.87. What is the ratio of the Value added (constant 2005 US$) of Kyrgyz Republic in 2008 to that in 2010?
Your answer should be very brief. 0.99. What is the ratio of the Value added (constant 2005 US$) of Latin America(developing only) in 2008 to that in 2011?
Your answer should be compact. 0.91. What is the ratio of the Value added (constant 2005 US$) in Indonesia in 2008 to that in 2011?
Ensure brevity in your answer.  0.8. What is the ratio of the Value added (constant 2005 US$) of Kyrgyz Republic in 2008 to that in 2011?
Offer a very short reply. 0.91. What is the ratio of the Value added (constant 2005 US$) of Nicaragua in 2008 to that in 2011?
Make the answer very short. 0.92. What is the ratio of the Value added (constant 2005 US$) of Latin America(developing only) in 2008 to that in 2012?
Provide a short and direct response. 0.88. What is the ratio of the Value added (constant 2005 US$) in Indonesia in 2008 to that in 2012?
Your answer should be very brief. 0.75. What is the ratio of the Value added (constant 2005 US$) of Kyrgyz Republic in 2008 to that in 2012?
Give a very brief answer. 0.89. What is the ratio of the Value added (constant 2005 US$) in Nicaragua in 2008 to that in 2012?
Provide a short and direct response. 0.88. What is the ratio of the Value added (constant 2005 US$) of Latin America(developing only) in 2009 to that in 2010?
Your answer should be compact. 0.95. What is the ratio of the Value added (constant 2005 US$) in Indonesia in 2009 to that in 2010?
Offer a very short reply. 0.92. What is the ratio of the Value added (constant 2005 US$) in Nicaragua in 2009 to that in 2010?
Make the answer very short. 0.95. What is the ratio of the Value added (constant 2005 US$) in Latin America(developing only) in 2009 to that in 2011?
Your response must be concise. 0.91. What is the ratio of the Value added (constant 2005 US$) of Indonesia in 2009 to that in 2011?
Your answer should be very brief. 0.85. What is the ratio of the Value added (constant 2005 US$) of Kyrgyz Republic in 2009 to that in 2011?
Provide a short and direct response. 0.92. What is the ratio of the Value added (constant 2005 US$) of Nicaragua in 2009 to that in 2011?
Your response must be concise. 0.91. What is the ratio of the Value added (constant 2005 US$) of Indonesia in 2009 to that in 2012?
Your response must be concise. 0.8. What is the ratio of the Value added (constant 2005 US$) of Kyrgyz Republic in 2009 to that in 2012?
Your answer should be compact. 0.9. What is the ratio of the Value added (constant 2005 US$) of Nicaragua in 2009 to that in 2012?
Ensure brevity in your answer.  0.87. What is the ratio of the Value added (constant 2005 US$) in Latin America(developing only) in 2010 to that in 2011?
Make the answer very short. 0.96. What is the ratio of the Value added (constant 2005 US$) in Indonesia in 2010 to that in 2011?
Offer a very short reply. 0.92. What is the ratio of the Value added (constant 2005 US$) in Kyrgyz Republic in 2010 to that in 2011?
Provide a short and direct response. 0.92. What is the ratio of the Value added (constant 2005 US$) of Nicaragua in 2010 to that in 2011?
Your response must be concise. 0.96. What is the ratio of the Value added (constant 2005 US$) in Latin America(developing only) in 2010 to that in 2012?
Make the answer very short. 0.92. What is the ratio of the Value added (constant 2005 US$) in Indonesia in 2010 to that in 2012?
Provide a short and direct response. 0.86. What is the ratio of the Value added (constant 2005 US$) in Kyrgyz Republic in 2010 to that in 2012?
Give a very brief answer. 0.9. What is the ratio of the Value added (constant 2005 US$) in Nicaragua in 2010 to that in 2012?
Your answer should be compact. 0.91. What is the ratio of the Value added (constant 2005 US$) in Latin America(developing only) in 2011 to that in 2012?
Offer a terse response. 0.97. What is the ratio of the Value added (constant 2005 US$) in Indonesia in 2011 to that in 2012?
Make the answer very short. 0.94. What is the ratio of the Value added (constant 2005 US$) in Kyrgyz Republic in 2011 to that in 2012?
Your response must be concise. 0.98. What is the ratio of the Value added (constant 2005 US$) in Nicaragua in 2011 to that in 2012?
Provide a succinct answer. 0.95. What is the difference between the highest and the second highest Value added (constant 2005 US$) of Latin America(developing only)?
Your answer should be very brief. 5.69e+1. What is the difference between the highest and the second highest Value added (constant 2005 US$) in Indonesia?
Your answer should be very brief. 1.24e+1. What is the difference between the highest and the second highest Value added (constant 2005 US$) of Kyrgyz Republic?
Make the answer very short. 4.44e+07. What is the difference between the highest and the second highest Value added (constant 2005 US$) of Nicaragua?
Provide a short and direct response. 2.38e+08. What is the difference between the highest and the lowest Value added (constant 2005 US$) of Latin America(developing only)?
Make the answer very short. 2.50e+11. What is the difference between the highest and the lowest Value added (constant 2005 US$) of Indonesia?
Offer a terse response. 5.98e+1. What is the difference between the highest and the lowest Value added (constant 2005 US$) of Kyrgyz Republic?
Keep it short and to the point. 3.87e+08. What is the difference between the highest and the lowest Value added (constant 2005 US$) in Nicaragua?
Offer a very short reply. 7.78e+08. 